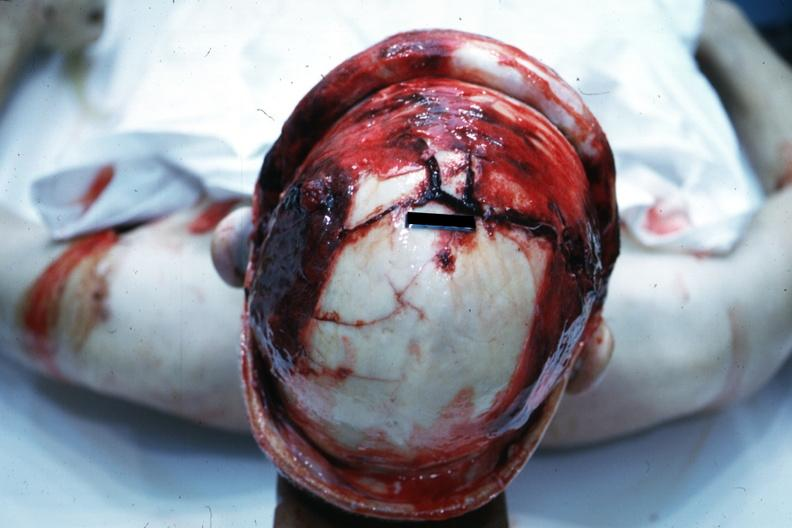does this typical thecoma with yellow foci show view of head with scalp retracted to show massive fractures?
Answer the question using a single word or phrase. No 